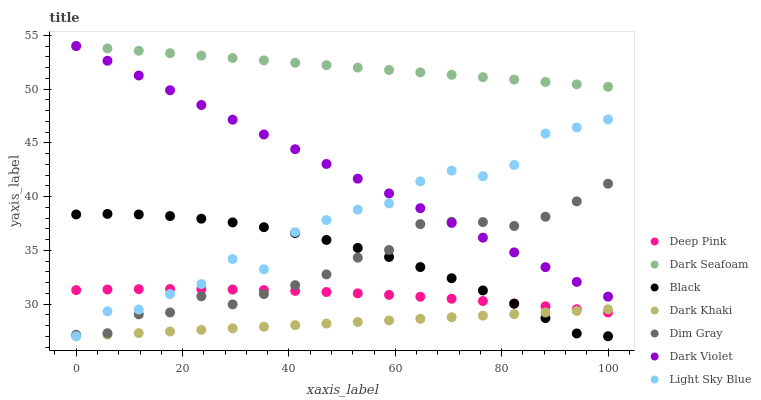Does Dark Khaki have the minimum area under the curve?
Answer yes or no. Yes. Does Dark Seafoam have the maximum area under the curve?
Answer yes or no. Yes. Does Dark Violet have the minimum area under the curve?
Answer yes or no. No. Does Dark Violet have the maximum area under the curve?
Answer yes or no. No. Is Dark Khaki the smoothest?
Answer yes or no. Yes. Is Light Sky Blue the roughest?
Answer yes or no. Yes. Is Dark Violet the smoothest?
Answer yes or no. No. Is Dark Violet the roughest?
Answer yes or no. No. Does Dark Khaki have the lowest value?
Answer yes or no. Yes. Does Dark Violet have the lowest value?
Answer yes or no. No. Does Dark Seafoam have the highest value?
Answer yes or no. Yes. Does Dark Khaki have the highest value?
Answer yes or no. No. Is Black less than Dark Seafoam?
Answer yes or no. Yes. Is Dark Seafoam greater than Light Sky Blue?
Answer yes or no. Yes. Does Black intersect Light Sky Blue?
Answer yes or no. Yes. Is Black less than Light Sky Blue?
Answer yes or no. No. Is Black greater than Light Sky Blue?
Answer yes or no. No. Does Black intersect Dark Seafoam?
Answer yes or no. No. 